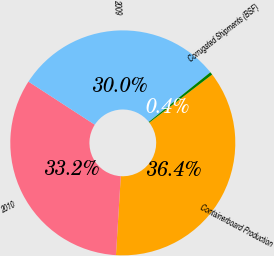Convert chart. <chart><loc_0><loc_0><loc_500><loc_500><pie_chart><fcel>Containerboard Production<fcel>2010<fcel>2009<fcel>Corrugated Shipments (BSF)<nl><fcel>36.36%<fcel>33.2%<fcel>30.03%<fcel>0.41%<nl></chart> 